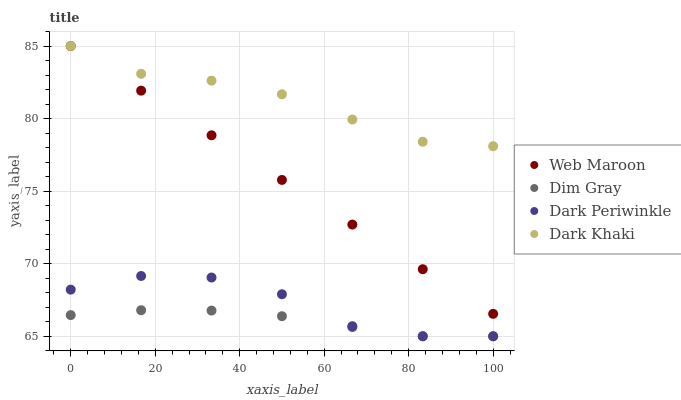Does Dim Gray have the minimum area under the curve?
Answer yes or no. Yes. Does Dark Khaki have the maximum area under the curve?
Answer yes or no. Yes. Does Web Maroon have the minimum area under the curve?
Answer yes or no. No. Does Web Maroon have the maximum area under the curve?
Answer yes or no. No. Is Web Maroon the smoothest?
Answer yes or no. Yes. Is Dark Periwinkle the roughest?
Answer yes or no. Yes. Is Dim Gray the smoothest?
Answer yes or no. No. Is Dim Gray the roughest?
Answer yes or no. No. Does Dim Gray have the lowest value?
Answer yes or no. Yes. Does Web Maroon have the lowest value?
Answer yes or no. No. Does Web Maroon have the highest value?
Answer yes or no. Yes. Does Dim Gray have the highest value?
Answer yes or no. No. Is Dim Gray less than Dark Khaki?
Answer yes or no. Yes. Is Dark Khaki greater than Dim Gray?
Answer yes or no. Yes. Does Web Maroon intersect Dark Khaki?
Answer yes or no. Yes. Is Web Maroon less than Dark Khaki?
Answer yes or no. No. Is Web Maroon greater than Dark Khaki?
Answer yes or no. No. Does Dim Gray intersect Dark Khaki?
Answer yes or no. No. 